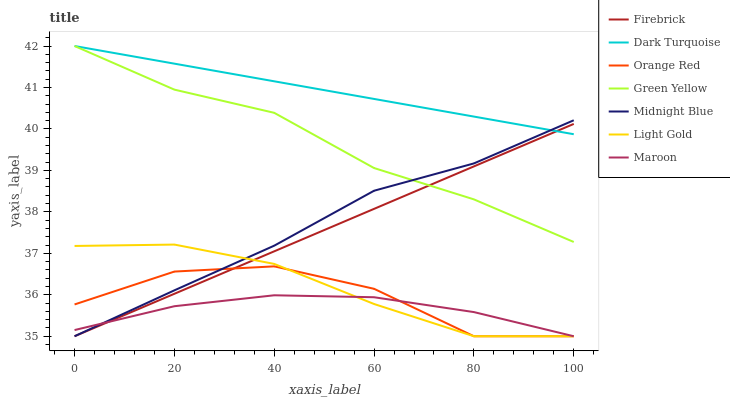Does Firebrick have the minimum area under the curve?
Answer yes or no. No. Does Firebrick have the maximum area under the curve?
Answer yes or no. No. Is Firebrick the smoothest?
Answer yes or no. No. Is Firebrick the roughest?
Answer yes or no. No. Does Dark Turquoise have the lowest value?
Answer yes or no. No. Does Firebrick have the highest value?
Answer yes or no. No. Is Orange Red less than Dark Turquoise?
Answer yes or no. Yes. Is Green Yellow greater than Orange Red?
Answer yes or no. Yes. Does Orange Red intersect Dark Turquoise?
Answer yes or no. No. 